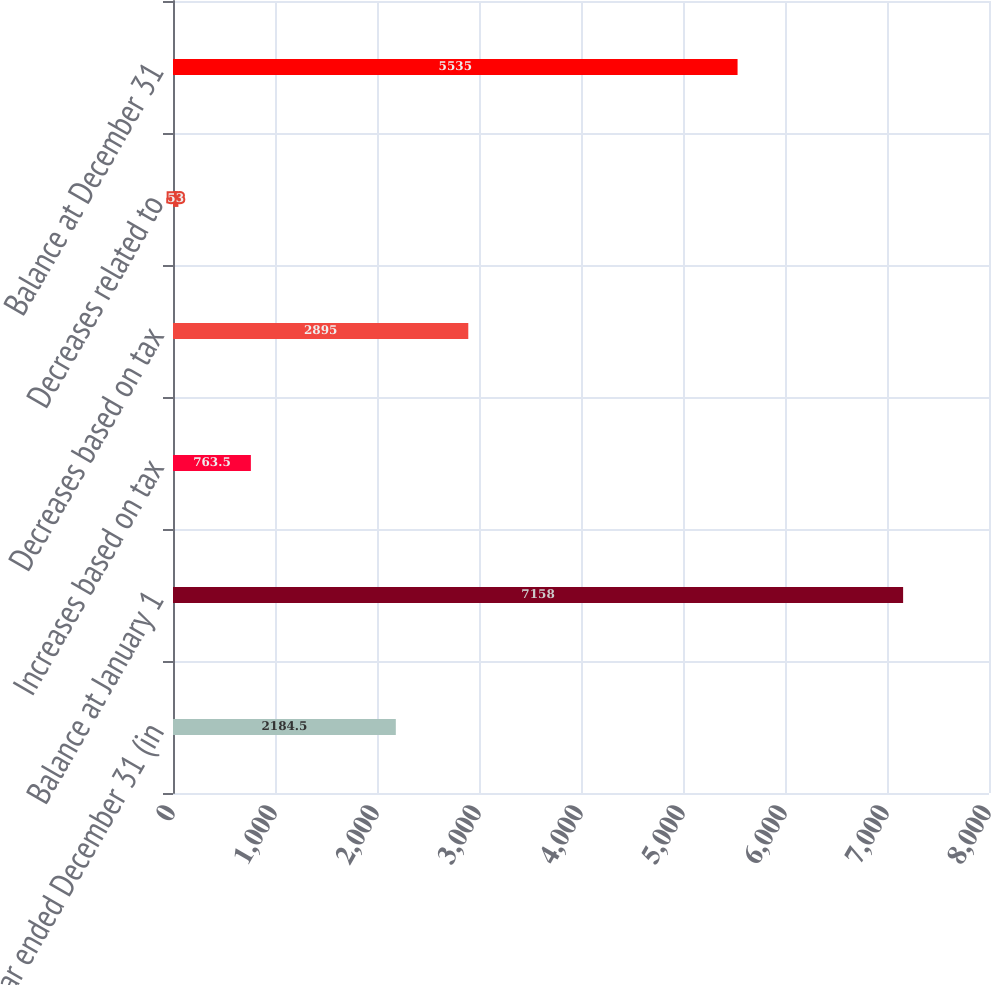<chart> <loc_0><loc_0><loc_500><loc_500><bar_chart><fcel>Year ended December 31 (in<fcel>Balance at January 1<fcel>Increases based on tax<fcel>Decreases based on tax<fcel>Decreases related to<fcel>Balance at December 31<nl><fcel>2184.5<fcel>7158<fcel>763.5<fcel>2895<fcel>53<fcel>5535<nl></chart> 